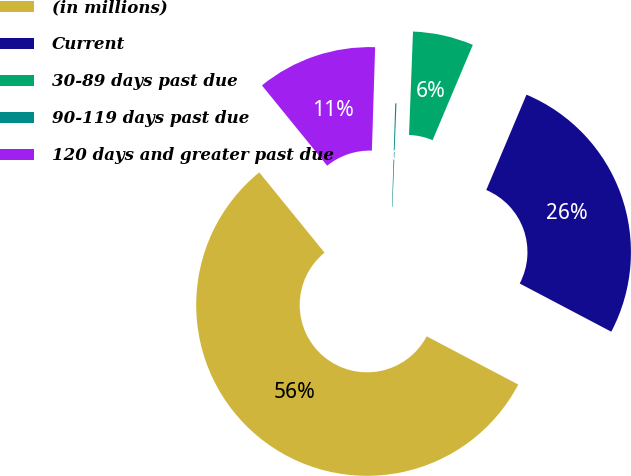Convert chart to OTSL. <chart><loc_0><loc_0><loc_500><loc_500><pie_chart><fcel>(in millions)<fcel>Current<fcel>30-89 days past due<fcel>90-119 days past due<fcel>120 days and greater past due<nl><fcel>56.42%<fcel>26.36%<fcel>5.74%<fcel>0.11%<fcel>11.37%<nl></chart> 